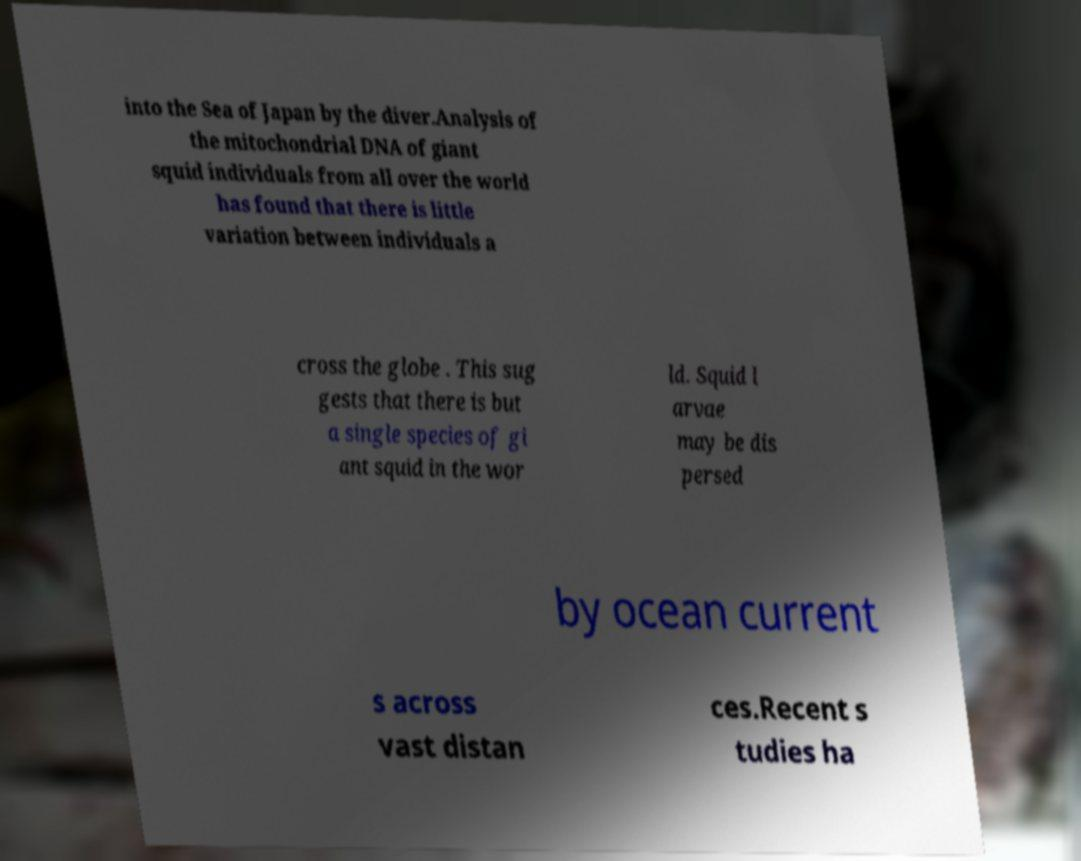Could you extract and type out the text from this image? into the Sea of Japan by the diver.Analysis of the mitochondrial DNA of giant squid individuals from all over the world has found that there is little variation between individuals a cross the globe . This sug gests that there is but a single species of gi ant squid in the wor ld. Squid l arvae may be dis persed by ocean current s across vast distan ces.Recent s tudies ha 